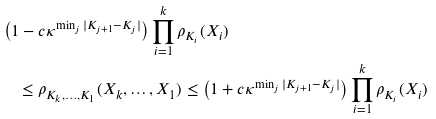<formula> <loc_0><loc_0><loc_500><loc_500>& \left ( 1 - c \kappa ^ { \min _ { j } | K _ { j + 1 } - K _ { j } | } \right ) \prod _ { i = 1 } ^ { k } \rho _ { K _ { i } } ( X _ { i } ) \\ & \quad \leq \rho _ { K _ { k } , \dots , K _ { 1 } } ( X _ { k } , \dots , X _ { 1 } ) \leq \left ( 1 + c \kappa ^ { \min _ { j } | K _ { j + 1 } - K _ { j } | } \right ) \prod _ { i = 1 } ^ { k } \rho _ { K _ { i } } ( X _ { i } )</formula> 